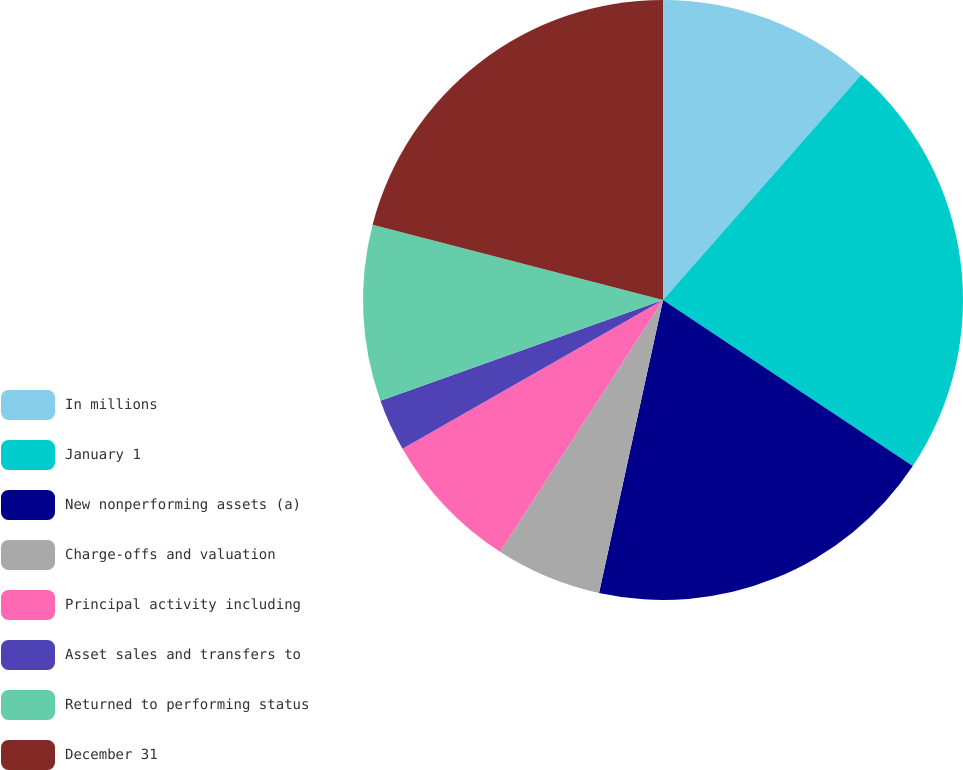Convert chart. <chart><loc_0><loc_0><loc_500><loc_500><pie_chart><fcel>In millions<fcel>January 1<fcel>New nonperforming assets (a)<fcel>Charge-offs and valuation<fcel>Principal activity including<fcel>Asset sales and transfers to<fcel>Returned to performing status<fcel>December 31<nl><fcel>11.49%<fcel>22.85%<fcel>19.08%<fcel>5.72%<fcel>7.6%<fcel>2.81%<fcel>9.49%<fcel>20.96%<nl></chart> 